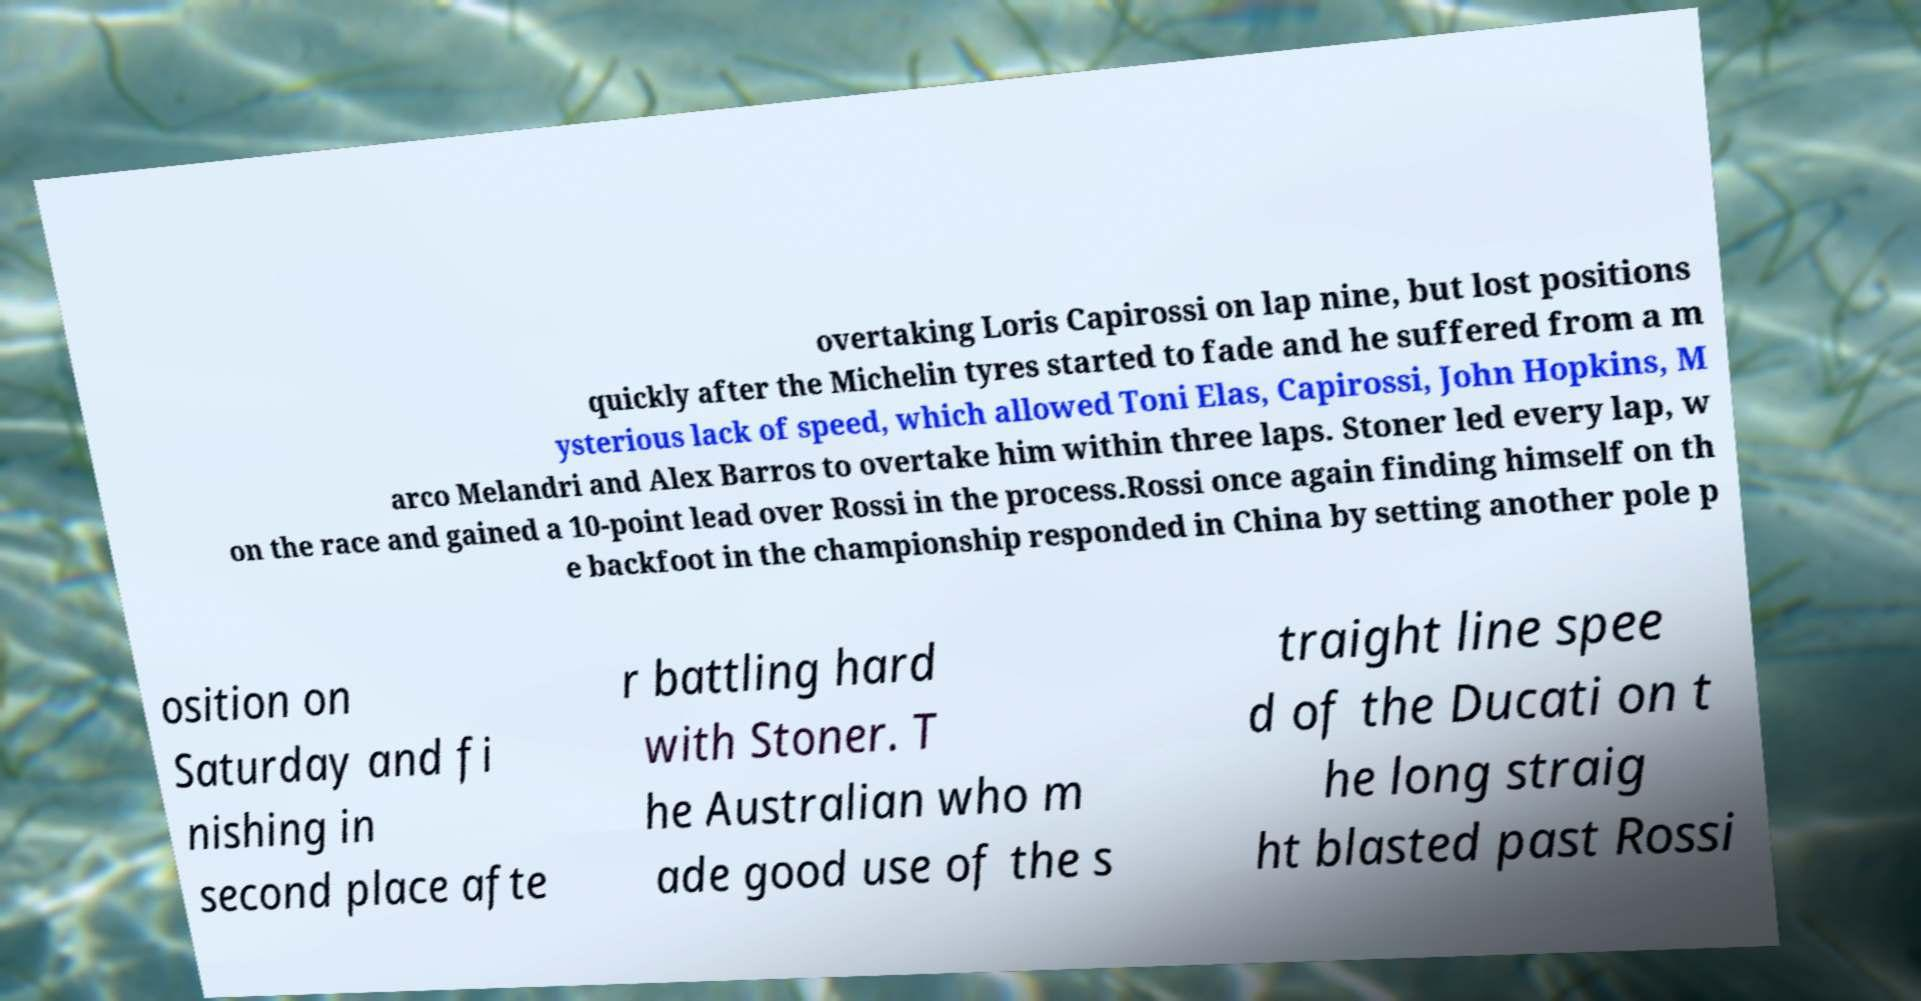Can you read and provide the text displayed in the image?This photo seems to have some interesting text. Can you extract and type it out for me? overtaking Loris Capirossi on lap nine, but lost positions quickly after the Michelin tyres started to fade and he suffered from a m ysterious lack of speed, which allowed Toni Elas, Capirossi, John Hopkins, M arco Melandri and Alex Barros to overtake him within three laps. Stoner led every lap, w on the race and gained a 10-point lead over Rossi in the process.Rossi once again finding himself on th e backfoot in the championship responded in China by setting another pole p osition on Saturday and fi nishing in second place afte r battling hard with Stoner. T he Australian who m ade good use of the s traight line spee d of the Ducati on t he long straig ht blasted past Rossi 